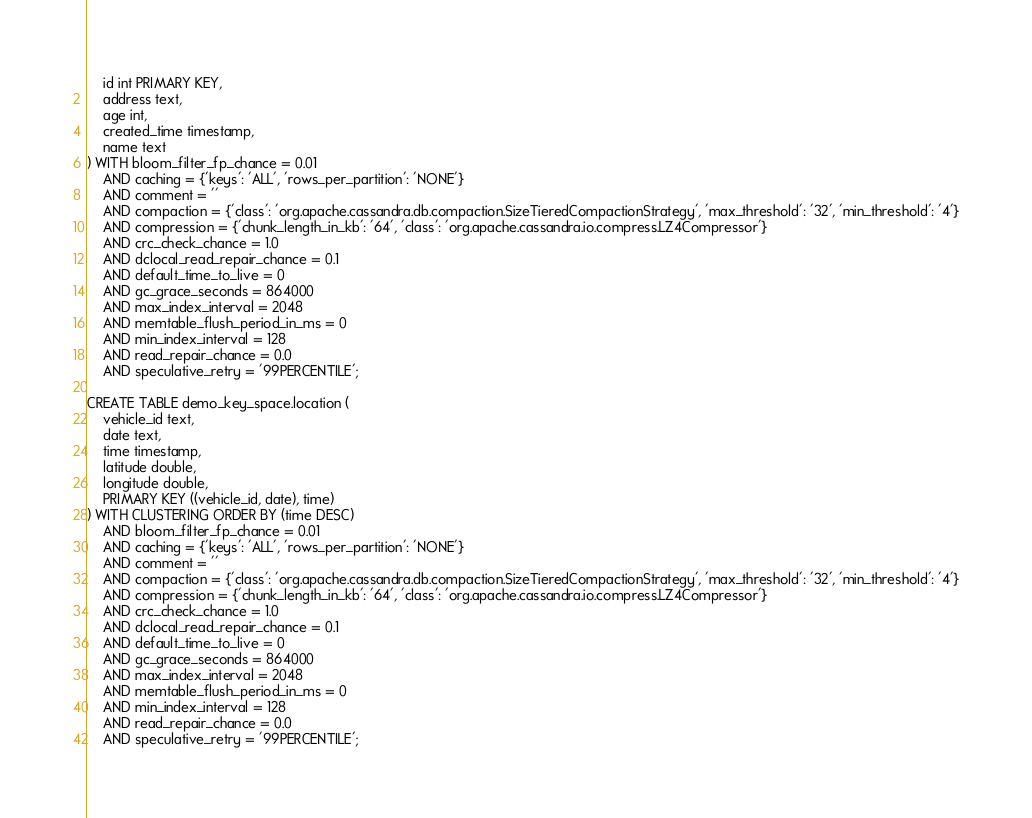<code> <loc_0><loc_0><loc_500><loc_500><_SQL_>    id int PRIMARY KEY,
    address text,
    age int,
    created_time timestamp,
    name text
) WITH bloom_filter_fp_chance = 0.01
    AND caching = {'keys': 'ALL', 'rows_per_partition': 'NONE'}
    AND comment = ''
    AND compaction = {'class': 'org.apache.cassandra.db.compaction.SizeTieredCompactionStrategy', 'max_threshold': '32', 'min_threshold': '4'}
    AND compression = {'chunk_length_in_kb': '64', 'class': 'org.apache.cassandra.io.compress.LZ4Compressor'}
    AND crc_check_chance = 1.0
    AND dclocal_read_repair_chance = 0.1
    AND default_time_to_live = 0
    AND gc_grace_seconds = 864000
    AND max_index_interval = 2048
    AND memtable_flush_period_in_ms = 0
    AND min_index_interval = 128
    AND read_repair_chance = 0.0
    AND speculative_retry = '99PERCENTILE';

CREATE TABLE demo_key_space.location (
    vehicle_id text,
    date text,
    time timestamp,
    latitude double,
    longitude double,
    PRIMARY KEY ((vehicle_id, date), time)
) WITH CLUSTERING ORDER BY (time DESC)
    AND bloom_filter_fp_chance = 0.01
    AND caching = {'keys': 'ALL', 'rows_per_partition': 'NONE'}
    AND comment = ''
    AND compaction = {'class': 'org.apache.cassandra.db.compaction.SizeTieredCompactionStrategy', 'max_threshold': '32', 'min_threshold': '4'}
    AND compression = {'chunk_length_in_kb': '64', 'class': 'org.apache.cassandra.io.compress.LZ4Compressor'}
    AND crc_check_chance = 1.0
    AND dclocal_read_repair_chance = 0.1
    AND default_time_to_live = 0
    AND gc_grace_seconds = 864000
    AND max_index_interval = 2048
    AND memtable_flush_period_in_ms = 0
    AND min_index_interval = 128
    AND read_repair_chance = 0.0
    AND speculative_retry = '99PERCENTILE';
</code> 